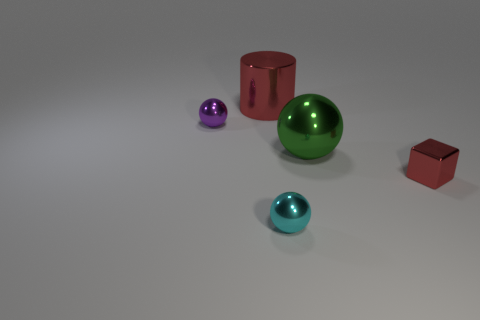Is there any other thing that is the same shape as the big red metallic thing?
Your answer should be compact. No. There is a green thing that is the same shape as the tiny cyan object; what size is it?
Provide a succinct answer. Large. How many other things are there of the same material as the block?
Your answer should be compact. 4. What is the large sphere made of?
Offer a very short reply. Metal. There is a large shiny object that is behind the small purple sphere; does it have the same color as the small thing that is to the right of the small cyan ball?
Keep it short and to the point. Yes. Is the number of shiny cylinders behind the green ball greater than the number of tiny yellow rubber spheres?
Keep it short and to the point. Yes. What number of other objects are there of the same color as the large cylinder?
Keep it short and to the point. 1. Is the size of the object in front of the cube the same as the cylinder?
Provide a succinct answer. No. Is there a purple metal ball of the same size as the cyan shiny ball?
Keep it short and to the point. Yes. There is a large shiny thing behind the tiny purple metallic object; what is its color?
Your answer should be very brief. Red. 